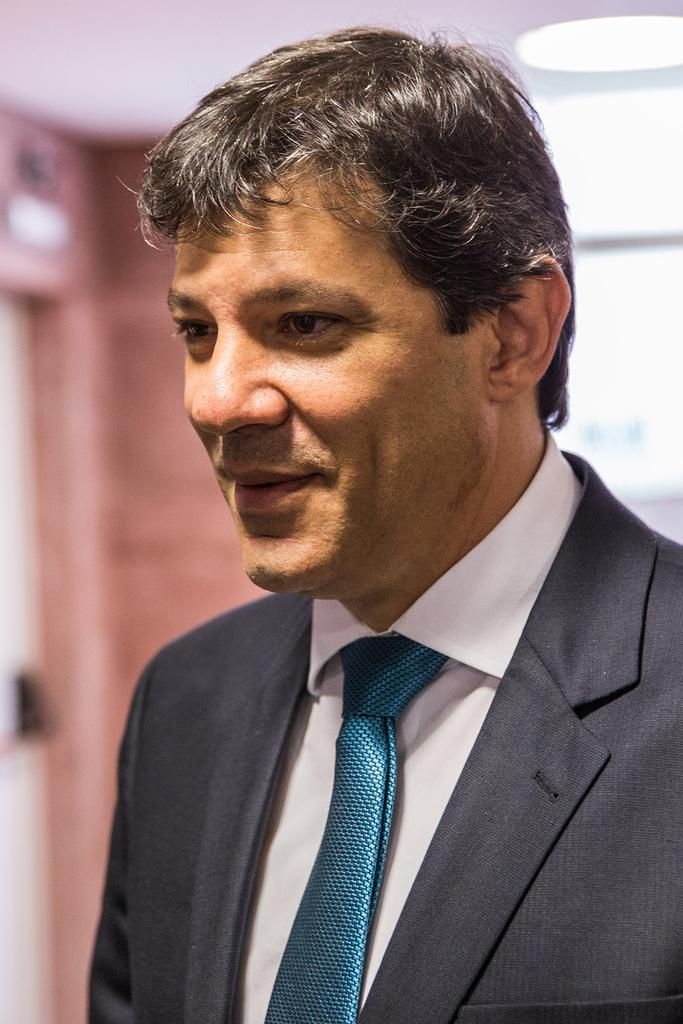What is present in the image? There is a man in the picture. Can you describe the background of the image? The background of the image is blurred. What type of dust can be seen on the man's clothes in the image? There is no dust visible on the man's clothes in the image. Is the sand visible in the image? There is no sand present in the image. 